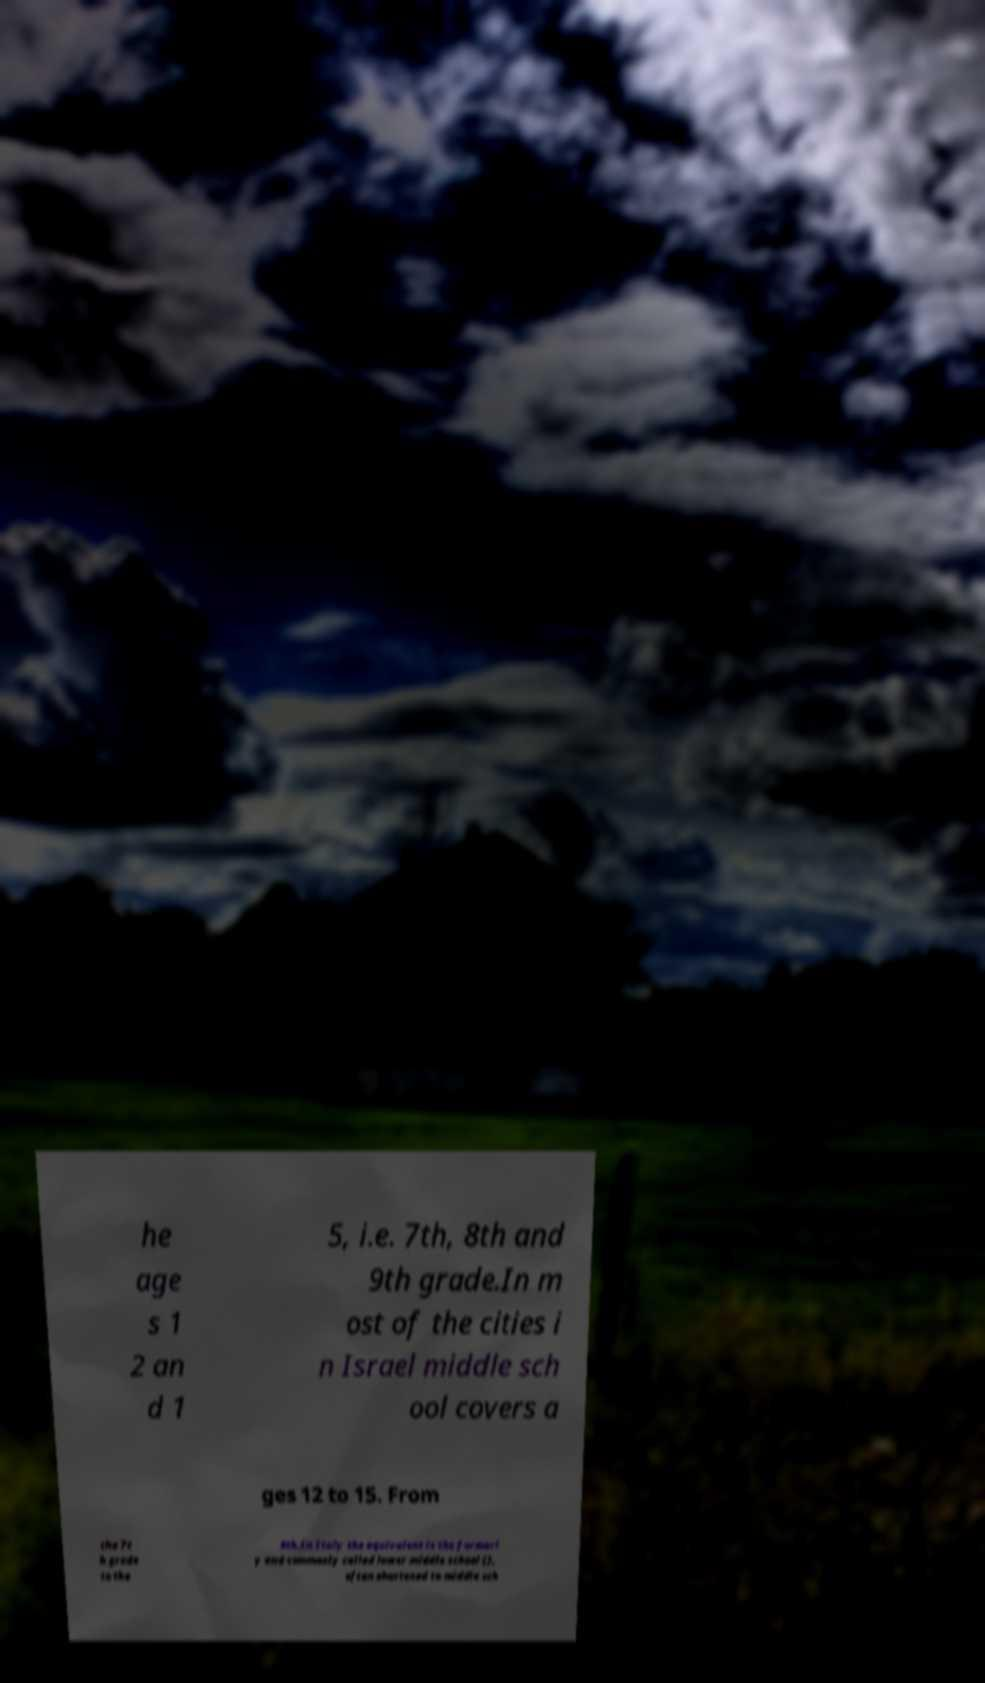Could you assist in decoding the text presented in this image and type it out clearly? he age s 1 2 an d 1 5, i.e. 7th, 8th and 9th grade.In m ost of the cities i n Israel middle sch ool covers a ges 12 to 15. From the 7t h grade to the 9th.In Italy the equivalent is the formerl y and commonly called lower middle school (), often shortened to middle sch 